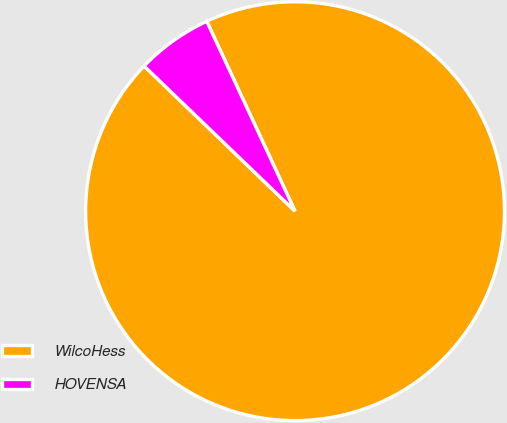Convert chart. <chart><loc_0><loc_0><loc_500><loc_500><pie_chart><fcel>WilcoHess<fcel>HOVENSA<nl><fcel>94.12%<fcel>5.88%<nl></chart> 